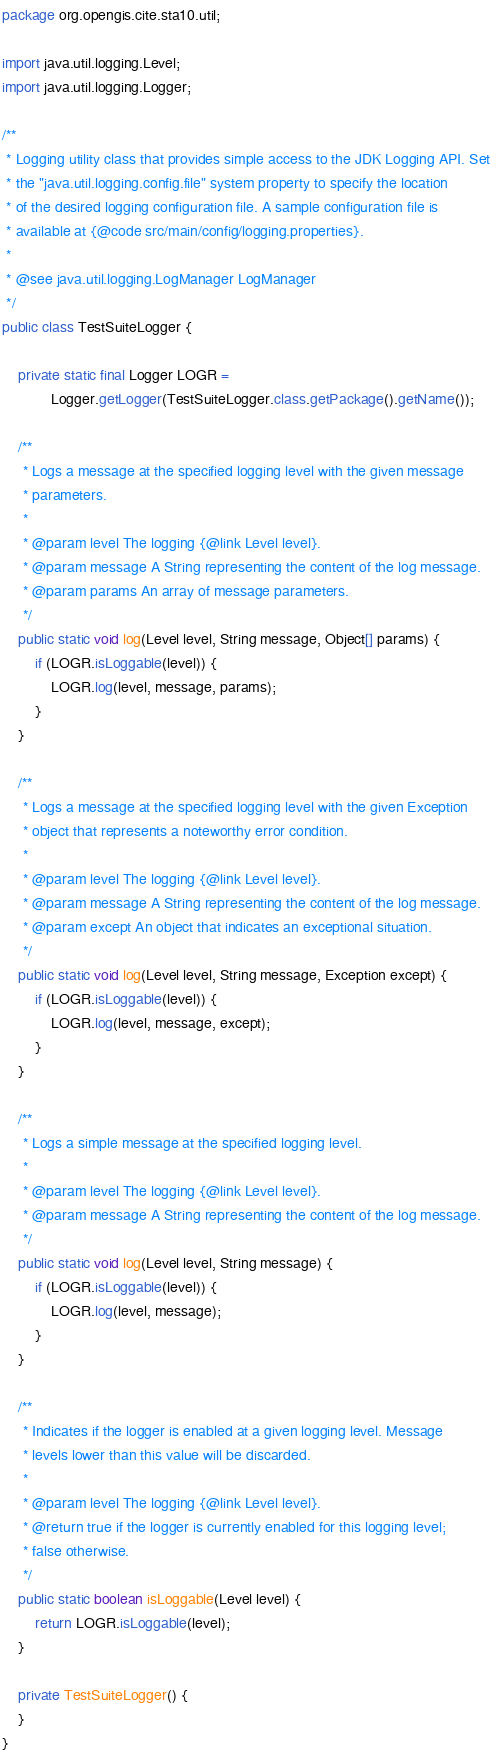Convert code to text. <code><loc_0><loc_0><loc_500><loc_500><_Java_>package org.opengis.cite.sta10.util;

import java.util.logging.Level;
import java.util.logging.Logger;

/**
 * Logging utility class that provides simple access to the JDK Logging API. Set
 * the "java.util.logging.config.file" system property to specify the location
 * of the desired logging configuration file. A sample configuration file is
 * available at {@code src/main/config/logging.properties}.
 *
 * @see java.util.logging.LogManager LogManager
 */
public class TestSuiteLogger {

    private static final Logger LOGR =
            Logger.getLogger(TestSuiteLogger.class.getPackage().getName());

    /**
     * Logs a message at the specified logging level with the given message
     * parameters.
     *
     * @param level The logging {@link Level level}.
     * @param message A String representing the content of the log message.
     * @param params An array of message parameters.
     */
    public static void log(Level level, String message, Object[] params) {
        if (LOGR.isLoggable(level)) {
            LOGR.log(level, message, params);
        }
    }

    /**
     * Logs a message at the specified logging level with the given Exception
     * object that represents a noteworthy error condition.
     *
     * @param level The logging {@link Level level}.
     * @param message A String representing the content of the log message.
     * @param except An object that indicates an exceptional situation.
     */
    public static void log(Level level, String message, Exception except) {
        if (LOGR.isLoggable(level)) {
            LOGR.log(level, message, except);
        }
    }

    /**
     * Logs a simple message at the specified logging level.
     *
     * @param level The logging {@link Level level}.
     * @param message A String representing the content of the log message.
     */
    public static void log(Level level, String message) {
        if (LOGR.isLoggable(level)) {
            LOGR.log(level, message);
        }
    }

    /**
     * Indicates if the logger is enabled at a given logging level. Message
     * levels lower than this value will be discarded.
     *
     * @param level The logging {@link Level level}.
     * @return true if the logger is currently enabled for this logging level;
     * false otherwise.
     */
    public static boolean isLoggable(Level level) {
        return LOGR.isLoggable(level);
    }

    private TestSuiteLogger() {
    }
}
</code> 